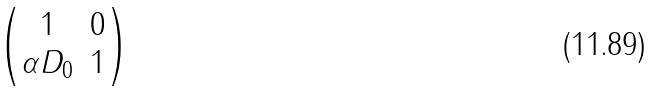<formula> <loc_0><loc_0><loc_500><loc_500>\begin{pmatrix} 1 & 0 \\ \alpha D _ { 0 } & 1 \end{pmatrix}</formula> 